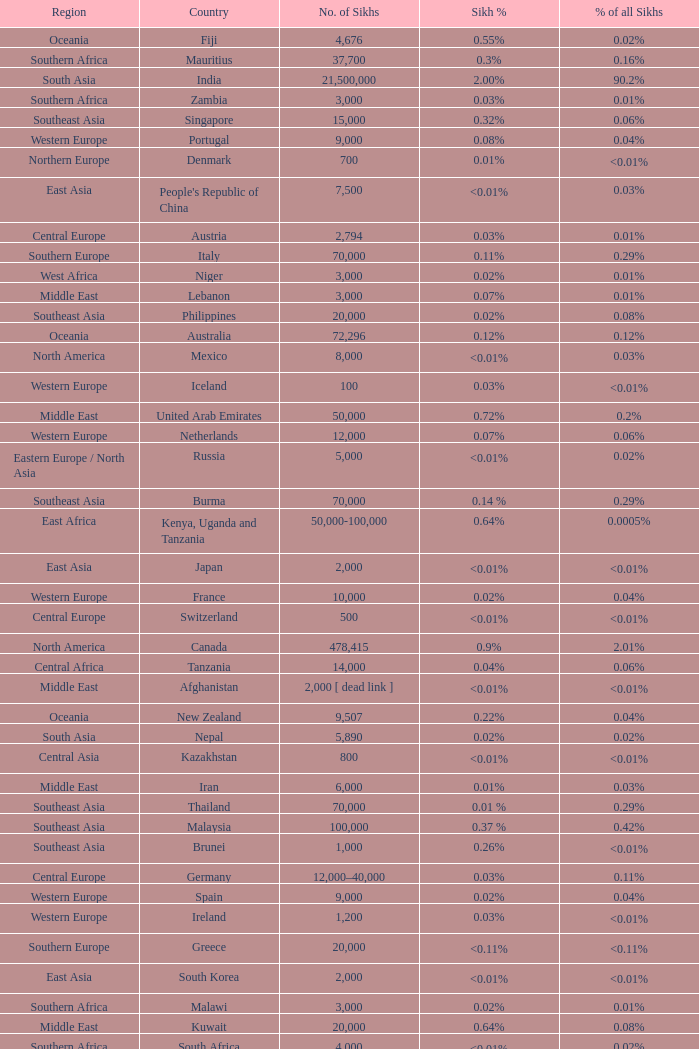What is the number of sikhs in Japan? 2000.0. 